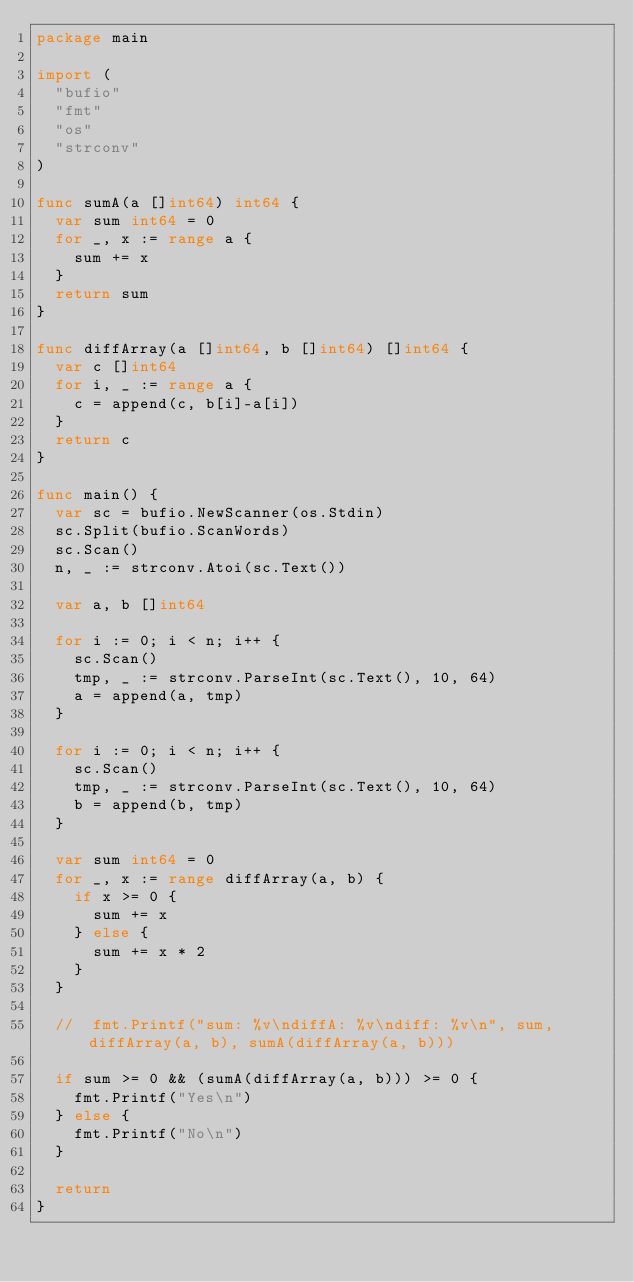<code> <loc_0><loc_0><loc_500><loc_500><_Go_>package main

import (
	"bufio"
	"fmt"
	"os"
	"strconv"
)

func sumA(a []int64) int64 {
	var sum int64 = 0
	for _, x := range a {
		sum += x
	}
	return sum
}

func diffArray(a []int64, b []int64) []int64 {
	var c []int64
	for i, _ := range a {
		c = append(c, b[i]-a[i])
	}
	return c
}

func main() {
	var sc = bufio.NewScanner(os.Stdin)
	sc.Split(bufio.ScanWords)
	sc.Scan()
	n, _ := strconv.Atoi(sc.Text())

	var a, b []int64

	for i := 0; i < n; i++ {
		sc.Scan()
		tmp, _ := strconv.ParseInt(sc.Text(), 10, 64)
		a = append(a, tmp)
	}

	for i := 0; i < n; i++ {
		sc.Scan()
		tmp, _ := strconv.ParseInt(sc.Text(), 10, 64)
		b = append(b, tmp)
	}

	var sum int64 = 0
	for _, x := range diffArray(a, b) {
		if x >= 0 {
			sum += x
		} else {
			sum += x * 2
		}
	}

	//	fmt.Printf("sum: %v\ndiffA: %v\ndiff: %v\n", sum, diffArray(a, b), sumA(diffArray(a, b)))

	if sum >= 0 && (sumA(diffArray(a, b))) >= 0 {
		fmt.Printf("Yes\n")
	} else {
		fmt.Printf("No\n")
	}

	return
}
</code> 